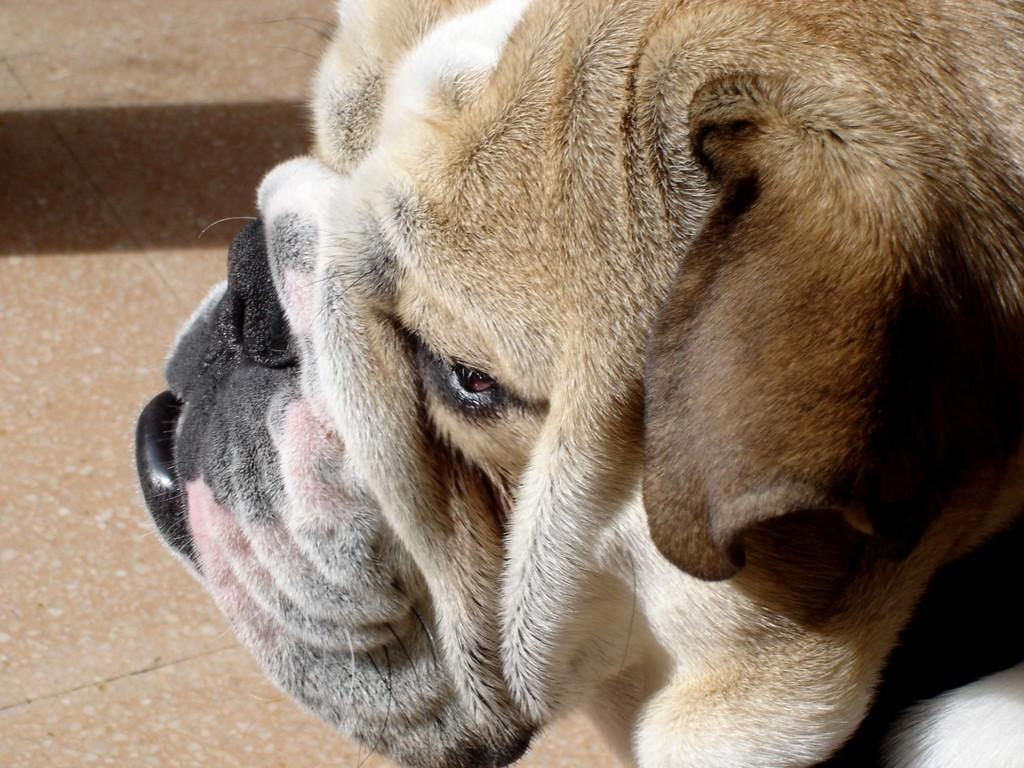What type of animal is present in the image? There is a dog in the image. Where is the dog located in the image? The dog is on the floor. What type of horn can be heard during the meeting in the image? There is no meeting or horn present in the image; it features a dog on the floor. What type of lunch is being served in the image? There is no lunch present in the image; it features a dog on the floor. 